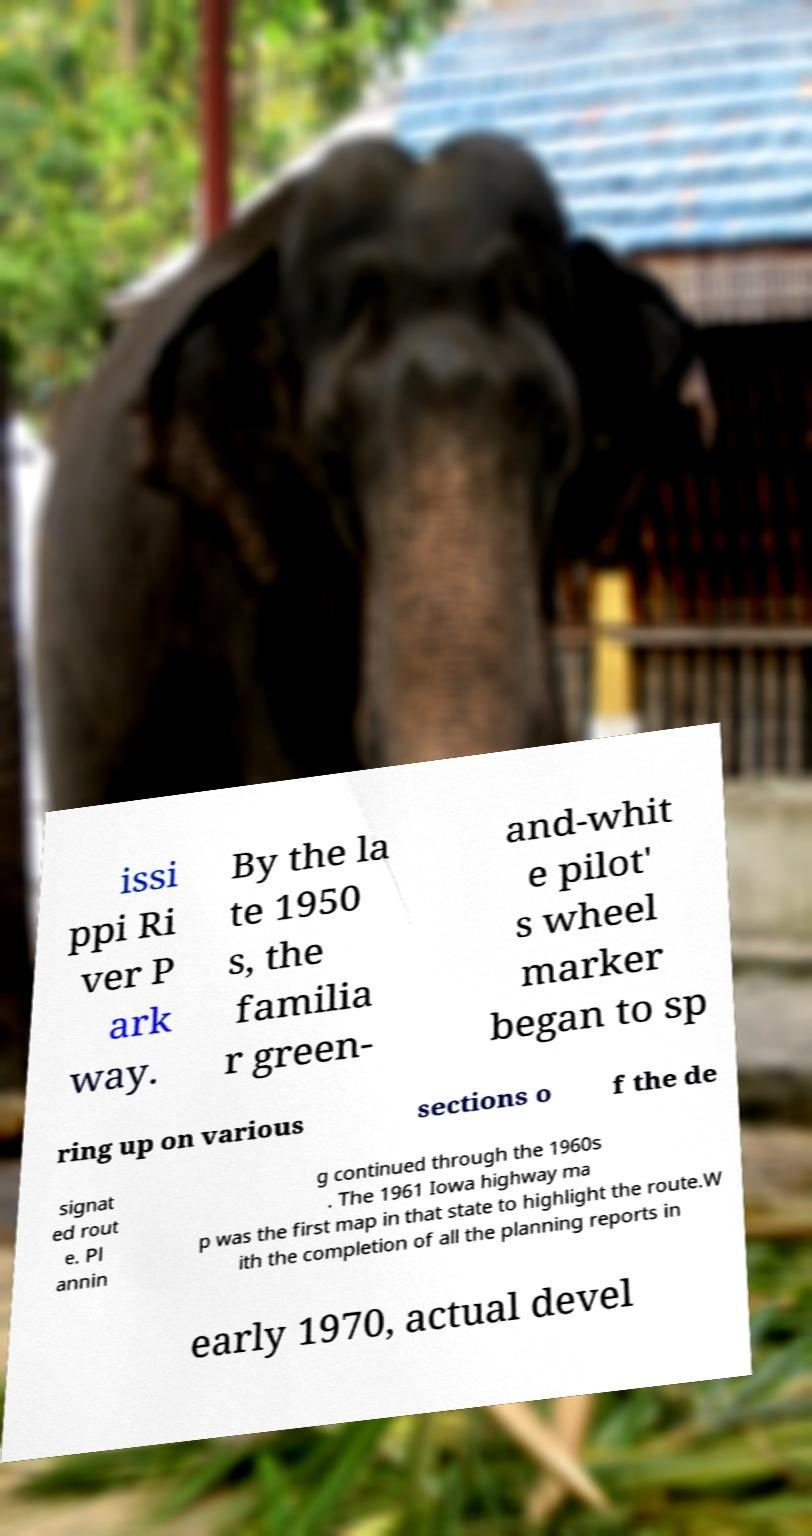For documentation purposes, I need the text within this image transcribed. Could you provide that? issi ppi Ri ver P ark way. By the la te 1950 s, the familia r green- and-whit e pilot' s wheel marker began to sp ring up on various sections o f the de signat ed rout e. Pl annin g continued through the 1960s . The 1961 Iowa highway ma p was the first map in that state to highlight the route.W ith the completion of all the planning reports in early 1970, actual devel 